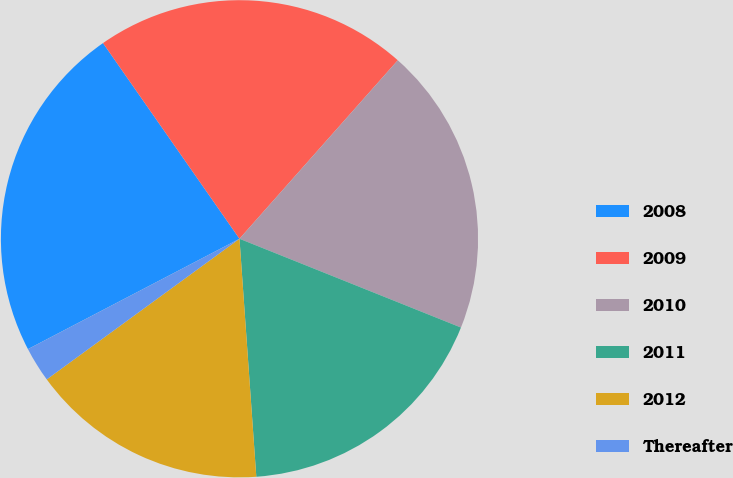<chart> <loc_0><loc_0><loc_500><loc_500><pie_chart><fcel>2008<fcel>2009<fcel>2010<fcel>2011<fcel>2012<fcel>Thereafter<nl><fcel>22.96%<fcel>21.24%<fcel>19.52%<fcel>17.81%<fcel>16.09%<fcel>2.38%<nl></chart> 